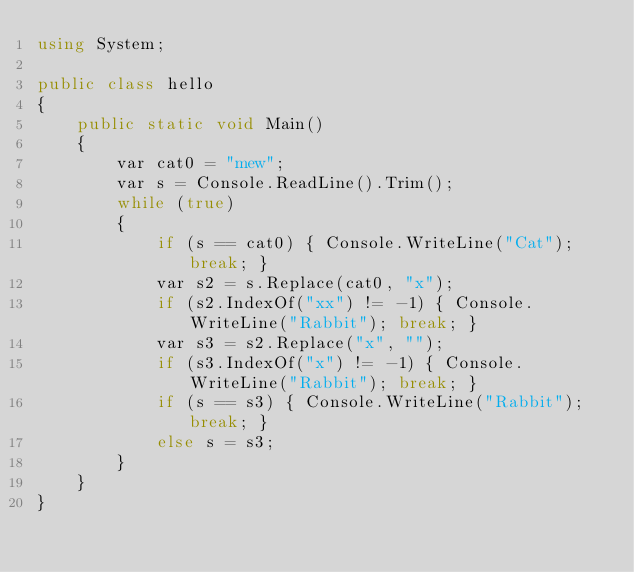<code> <loc_0><loc_0><loc_500><loc_500><_C#_>using System;

public class hello
{
    public static void Main()
    {
        var cat0 = "mew";
        var s = Console.ReadLine().Trim();
        while (true)
        {
            if (s == cat0) { Console.WriteLine("Cat"); break; }
            var s2 = s.Replace(cat0, "x");
            if (s2.IndexOf("xx") != -1) { Console.WriteLine("Rabbit"); break; }
            var s3 = s2.Replace("x", "");
            if (s3.IndexOf("x") != -1) { Console.WriteLine("Rabbit"); break; }
            if (s == s3) { Console.WriteLine("Rabbit"); break; }
            else s = s3;
        }
    }
}</code> 